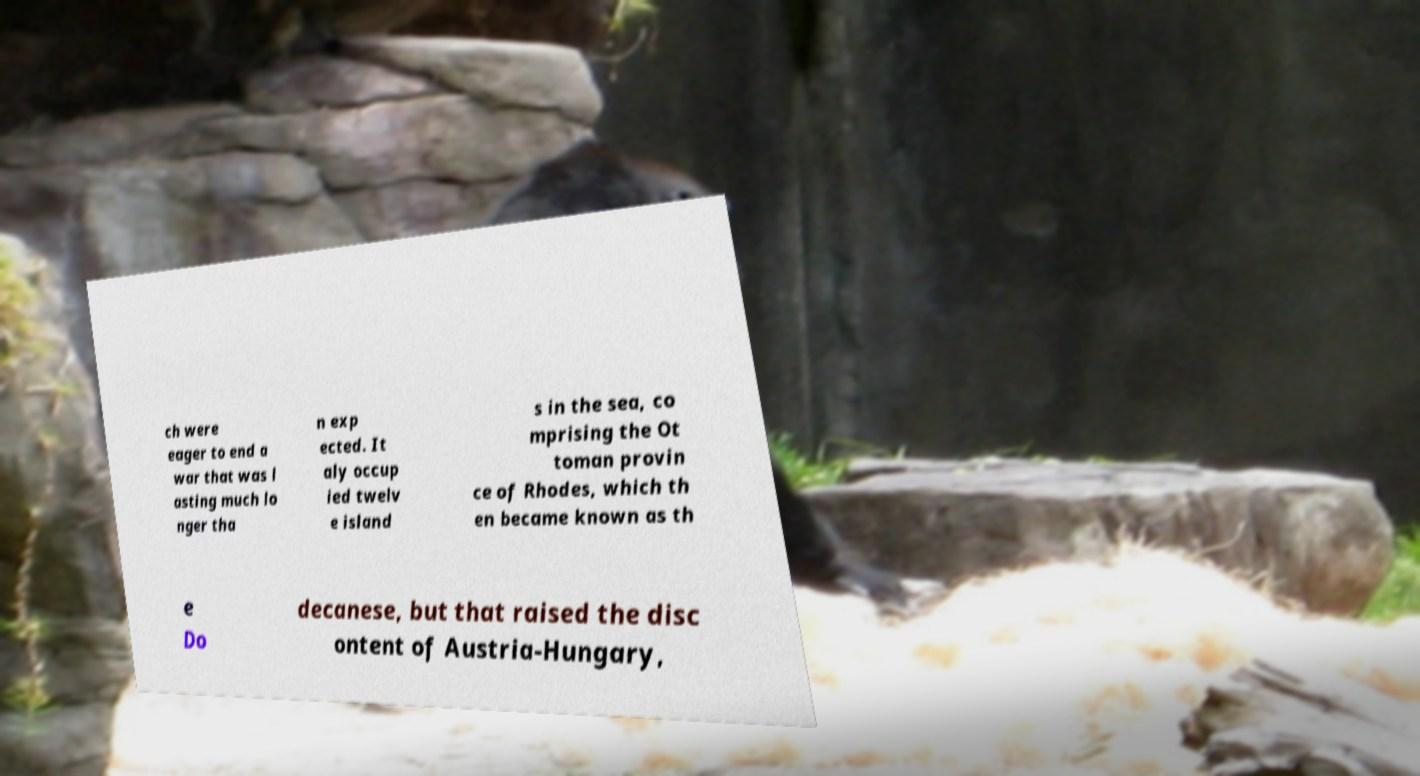Can you accurately transcribe the text from the provided image for me? ch were eager to end a war that was l asting much lo nger tha n exp ected. It aly occup ied twelv e island s in the sea, co mprising the Ot toman provin ce of Rhodes, which th en became known as th e Do decanese, but that raised the disc ontent of Austria-Hungary, 